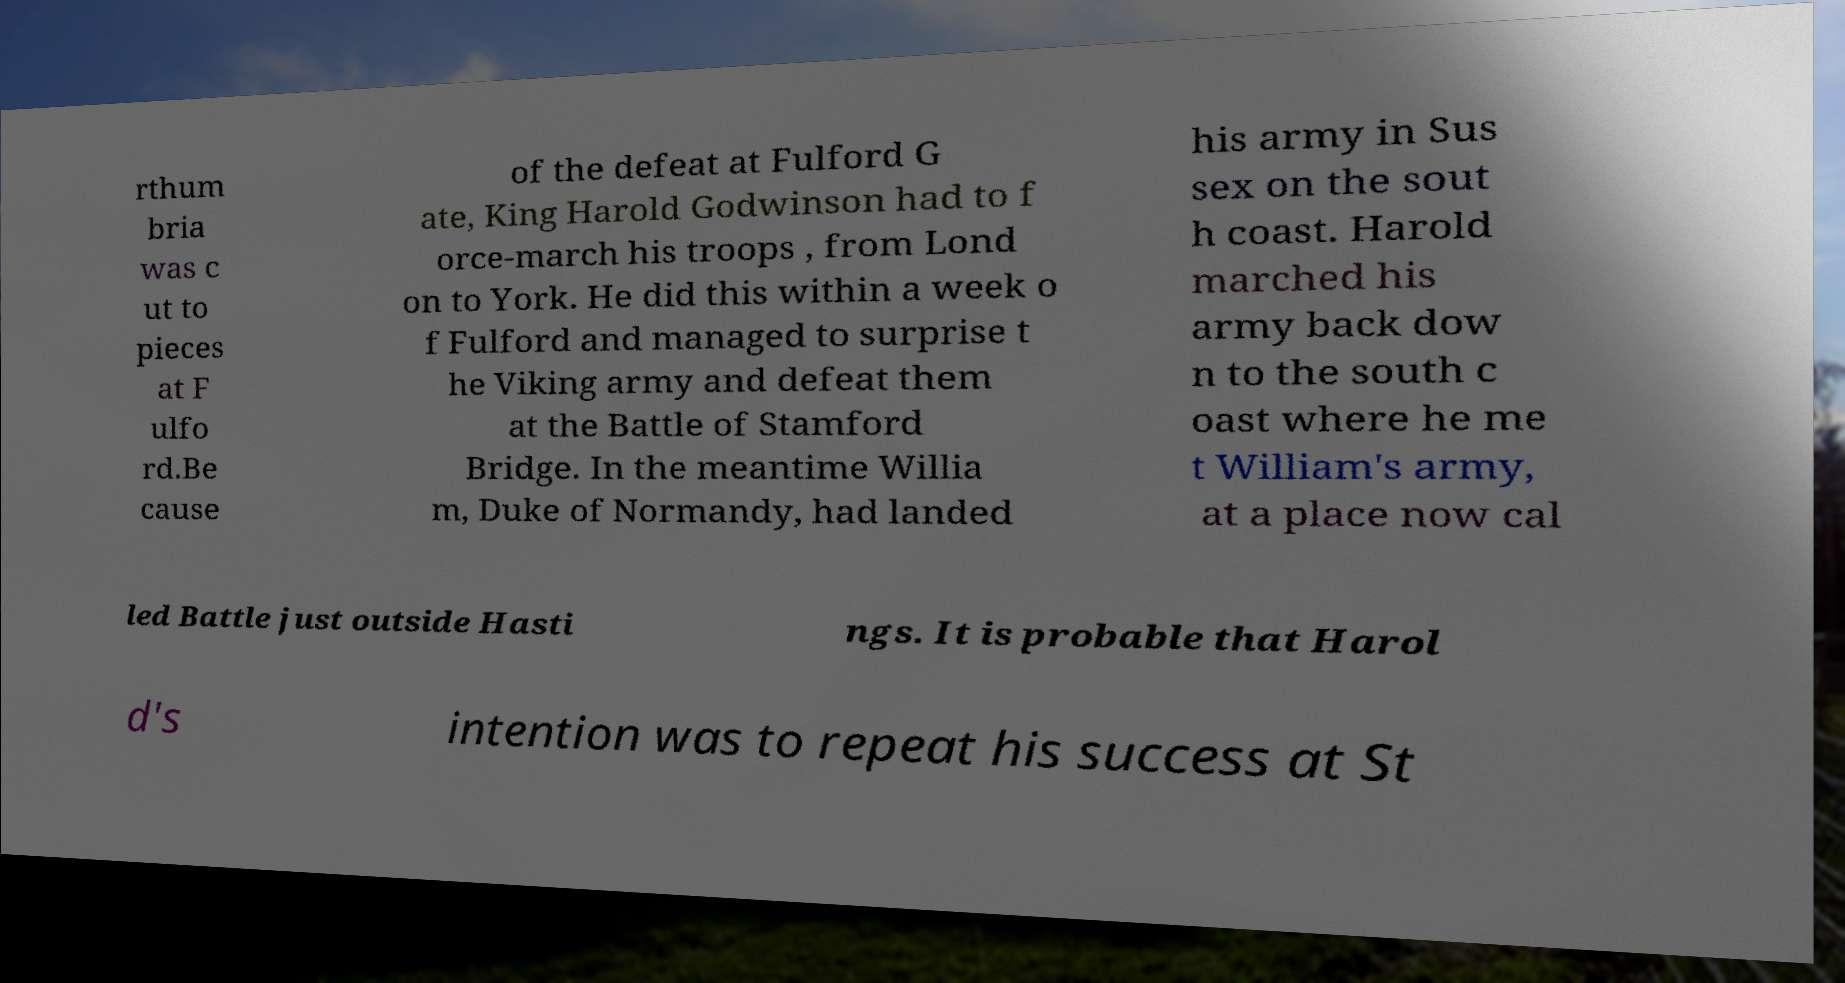Could you assist in decoding the text presented in this image and type it out clearly? rthum bria was c ut to pieces at F ulfo rd.Be cause of the defeat at Fulford G ate, King Harold Godwinson had to f orce-march his troops , from Lond on to York. He did this within a week o f Fulford and managed to surprise t he Viking army and defeat them at the Battle of Stamford Bridge. In the meantime Willia m, Duke of Normandy, had landed his army in Sus sex on the sout h coast. Harold marched his army back dow n to the south c oast where he me t William's army, at a place now cal led Battle just outside Hasti ngs. It is probable that Harol d's intention was to repeat his success at St 